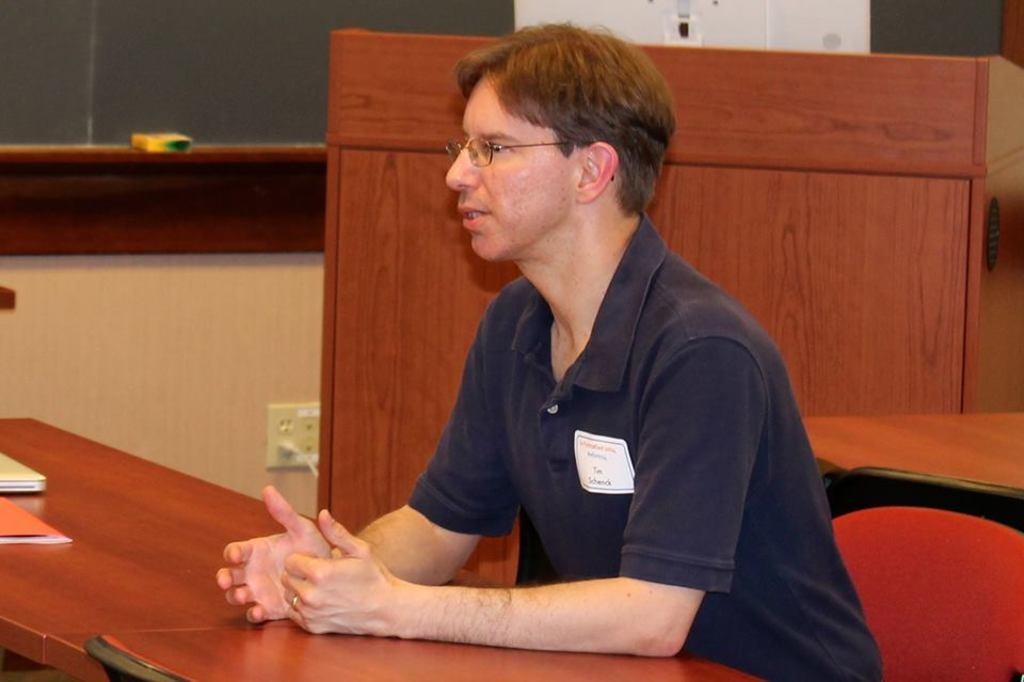What is the person in the image doing? The person is sitting on a chair in the image. What furniture is present in the image besides the chair? There are tables in the image. What items can be seen on the tables? There is a book and a laptop on one of the tables. What type of object is made of wood in the image? There is a wooden box in the image. What feature is present on the wall in the image? There is a socket on the wall in the image. What type of weather can be seen in the image? There is no weather visible in the image, as it is an indoor setting. 